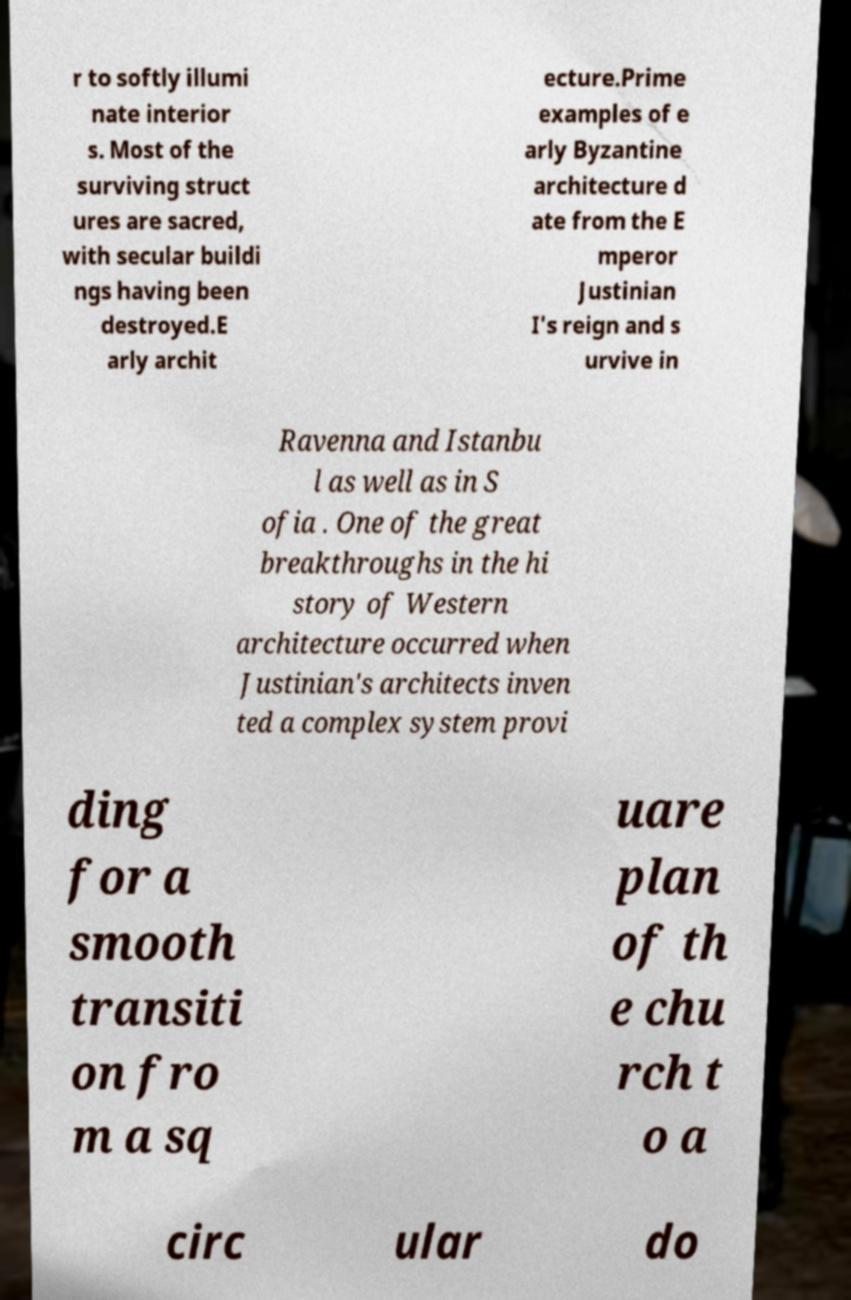I need the written content from this picture converted into text. Can you do that? r to softly illumi nate interior s. Most of the surviving struct ures are sacred, with secular buildi ngs having been destroyed.E arly archit ecture.Prime examples of e arly Byzantine architecture d ate from the E mperor Justinian I's reign and s urvive in Ravenna and Istanbu l as well as in S ofia . One of the great breakthroughs in the hi story of Western architecture occurred when Justinian's architects inven ted a complex system provi ding for a smooth transiti on fro m a sq uare plan of th e chu rch t o a circ ular do 